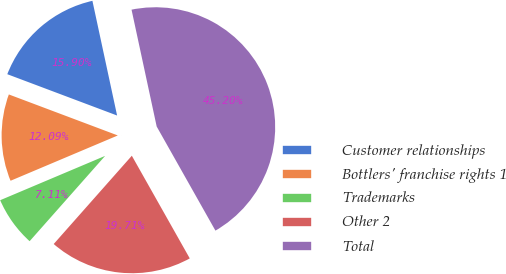Convert chart. <chart><loc_0><loc_0><loc_500><loc_500><pie_chart><fcel>Customer relationships<fcel>Bottlers' franchise rights 1<fcel>Trademarks<fcel>Other 2<fcel>Total<nl><fcel>15.9%<fcel>12.09%<fcel>7.11%<fcel>19.71%<fcel>45.2%<nl></chart> 